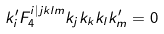<formula> <loc_0><loc_0><loc_500><loc_500>k _ { i } ^ { \prime } F _ { 4 } ^ { i | j k l m } k _ { j } k _ { k } k _ { l } k _ { m } ^ { \prime } = 0</formula> 